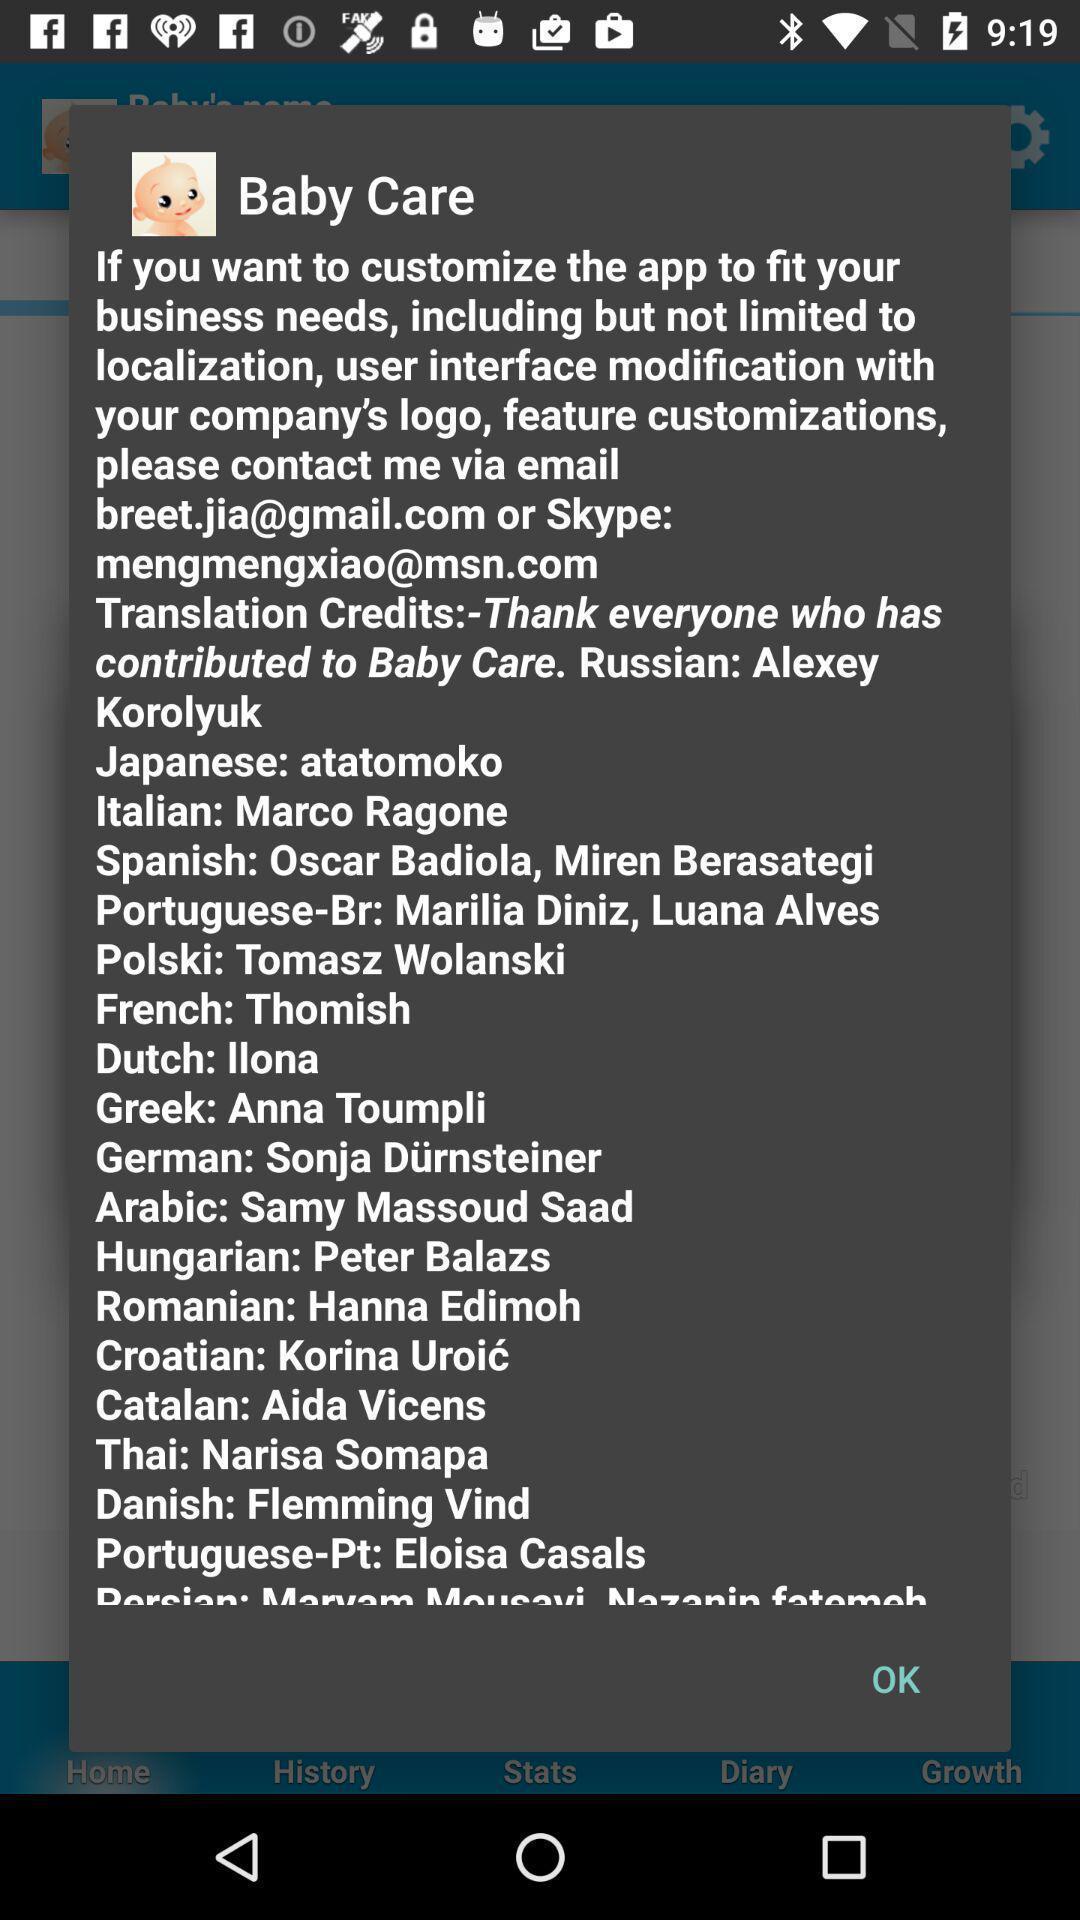Please provide a description for this image. Pop-up page displaying the information about the application. 